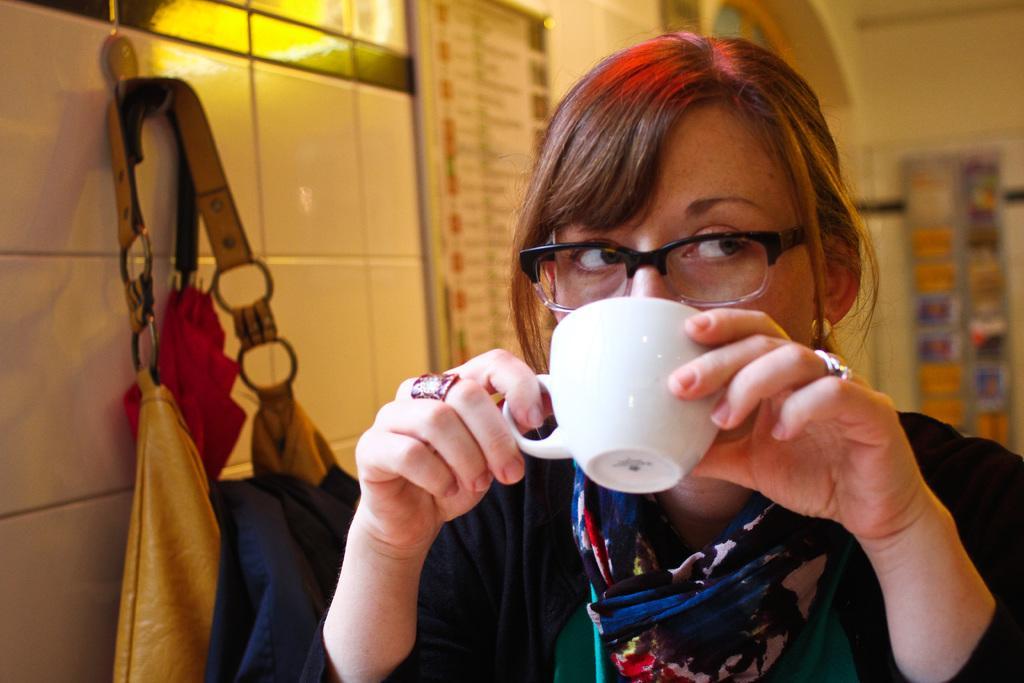Can you describe this image briefly? A woman is drinking the coffee in a cup also wearing spectacles 